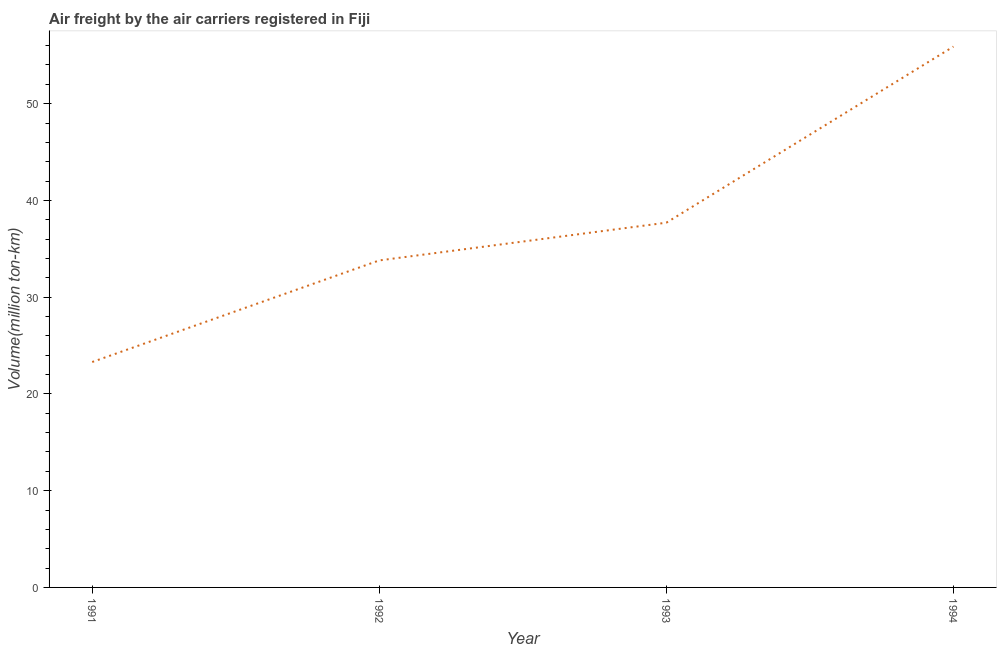What is the air freight in 1992?
Give a very brief answer. 33.8. Across all years, what is the maximum air freight?
Offer a very short reply. 55.9. Across all years, what is the minimum air freight?
Keep it short and to the point. 23.3. In which year was the air freight minimum?
Your response must be concise. 1991. What is the sum of the air freight?
Your answer should be very brief. 150.7. What is the difference between the air freight in 1991 and 1992?
Provide a short and direct response. -10.5. What is the average air freight per year?
Provide a succinct answer. 37.68. What is the median air freight?
Provide a succinct answer. 35.75. What is the ratio of the air freight in 1992 to that in 1993?
Provide a short and direct response. 0.9. Is the air freight in 1992 less than that in 1993?
Give a very brief answer. Yes. What is the difference between the highest and the second highest air freight?
Provide a short and direct response. 18.2. Is the sum of the air freight in 1991 and 1994 greater than the maximum air freight across all years?
Provide a short and direct response. Yes. What is the difference between the highest and the lowest air freight?
Offer a terse response. 32.6. In how many years, is the air freight greater than the average air freight taken over all years?
Provide a short and direct response. 2. How many lines are there?
Your response must be concise. 1. What is the difference between two consecutive major ticks on the Y-axis?
Your answer should be compact. 10. Are the values on the major ticks of Y-axis written in scientific E-notation?
Give a very brief answer. No. What is the title of the graph?
Your answer should be compact. Air freight by the air carriers registered in Fiji. What is the label or title of the Y-axis?
Provide a short and direct response. Volume(million ton-km). What is the Volume(million ton-km) in 1991?
Offer a terse response. 23.3. What is the Volume(million ton-km) of 1992?
Offer a very short reply. 33.8. What is the Volume(million ton-km) in 1993?
Provide a succinct answer. 37.7. What is the Volume(million ton-km) of 1994?
Your answer should be compact. 55.9. What is the difference between the Volume(million ton-km) in 1991 and 1992?
Your answer should be very brief. -10.5. What is the difference between the Volume(million ton-km) in 1991 and 1993?
Offer a very short reply. -14.4. What is the difference between the Volume(million ton-km) in 1991 and 1994?
Ensure brevity in your answer.  -32.6. What is the difference between the Volume(million ton-km) in 1992 and 1993?
Ensure brevity in your answer.  -3.9. What is the difference between the Volume(million ton-km) in 1992 and 1994?
Offer a very short reply. -22.1. What is the difference between the Volume(million ton-km) in 1993 and 1994?
Offer a terse response. -18.2. What is the ratio of the Volume(million ton-km) in 1991 to that in 1992?
Offer a very short reply. 0.69. What is the ratio of the Volume(million ton-km) in 1991 to that in 1993?
Provide a short and direct response. 0.62. What is the ratio of the Volume(million ton-km) in 1991 to that in 1994?
Your answer should be very brief. 0.42. What is the ratio of the Volume(million ton-km) in 1992 to that in 1993?
Provide a short and direct response. 0.9. What is the ratio of the Volume(million ton-km) in 1992 to that in 1994?
Your response must be concise. 0.6. What is the ratio of the Volume(million ton-km) in 1993 to that in 1994?
Provide a succinct answer. 0.67. 